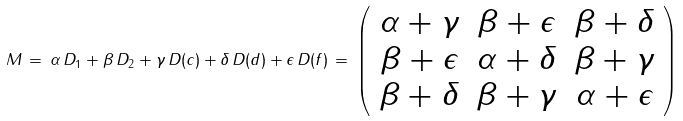<formula> <loc_0><loc_0><loc_500><loc_500>M \, = \, \alpha \, D _ { 1 } + \beta \, D _ { 2 } + \gamma \, D ( c ) + \delta \, D ( d ) + \epsilon \, D ( f ) \, = \, \left ( \begin{array} { c c c } \alpha + \gamma & \beta + \epsilon & \beta + \delta \\ \beta + \epsilon & \alpha + \delta & \beta + \gamma \\ \beta + \delta & \beta + \gamma & \alpha + \epsilon \end{array} \right )</formula> 